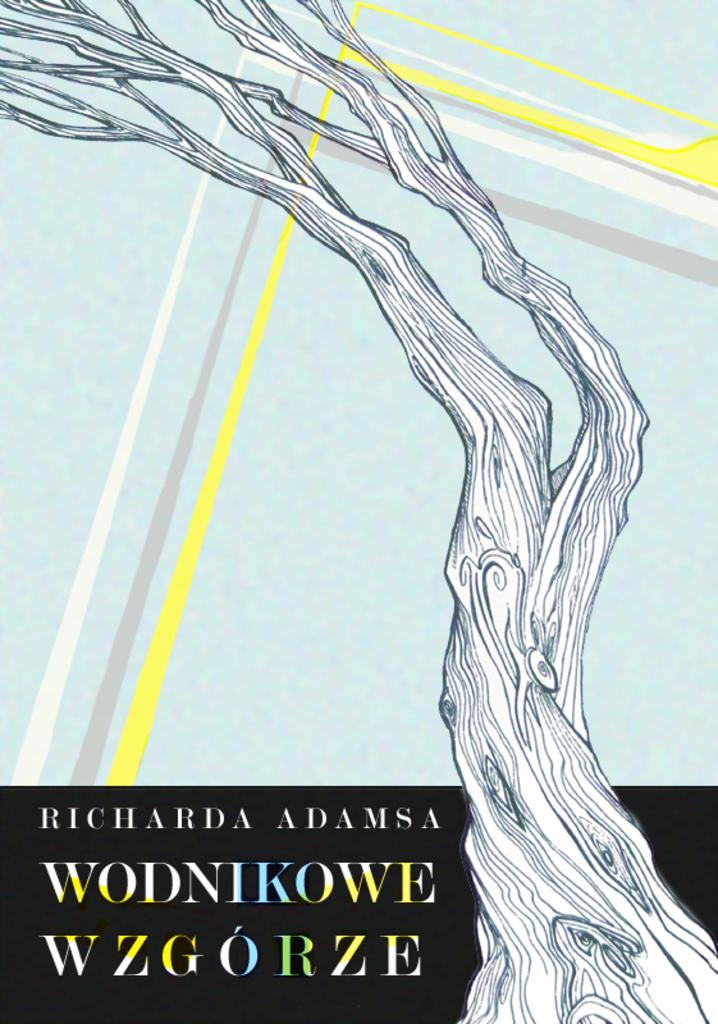What is the main subject in the image? There is a painting in the image. How many tramps are visible in the painting in the image? There is no tramp visible in the painting in the image. What type of birds can be seen building a nest in the painting? There is no painting of birds building a nest in the image. 